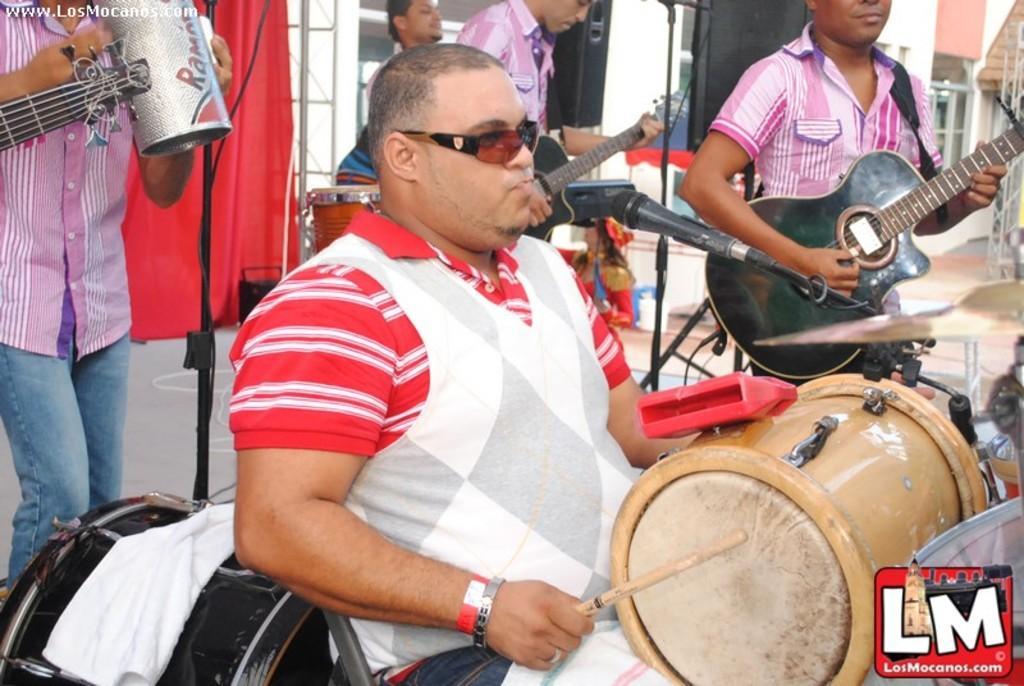Describe this image in one or two sentences. In this image, In the middle there is a man sitting and holding a music drum which is in yellow color he is holding a stick and he is playing a music drum, In the background there are some people standing and they are holding the music instruments, There is a man singing in the microphone which is in black color, 